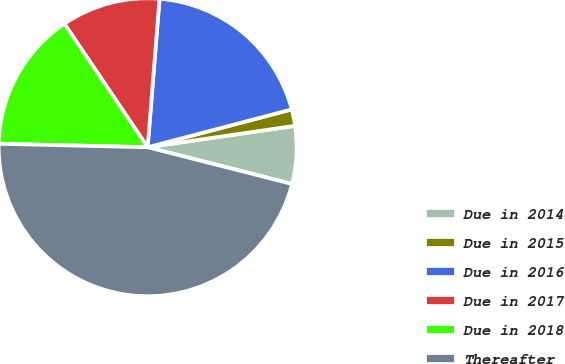Convert chart to OTSL. <chart><loc_0><loc_0><loc_500><loc_500><pie_chart><fcel>Due in 2014<fcel>Due in 2015<fcel>Due in 2016<fcel>Due in 2017<fcel>Due in 2018<fcel>Thereafter<nl><fcel>6.26%<fcel>1.79%<fcel>19.64%<fcel>10.72%<fcel>15.18%<fcel>46.41%<nl></chart> 